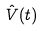Convert formula to latex. <formula><loc_0><loc_0><loc_500><loc_500>\hat { V } ( t )</formula> 